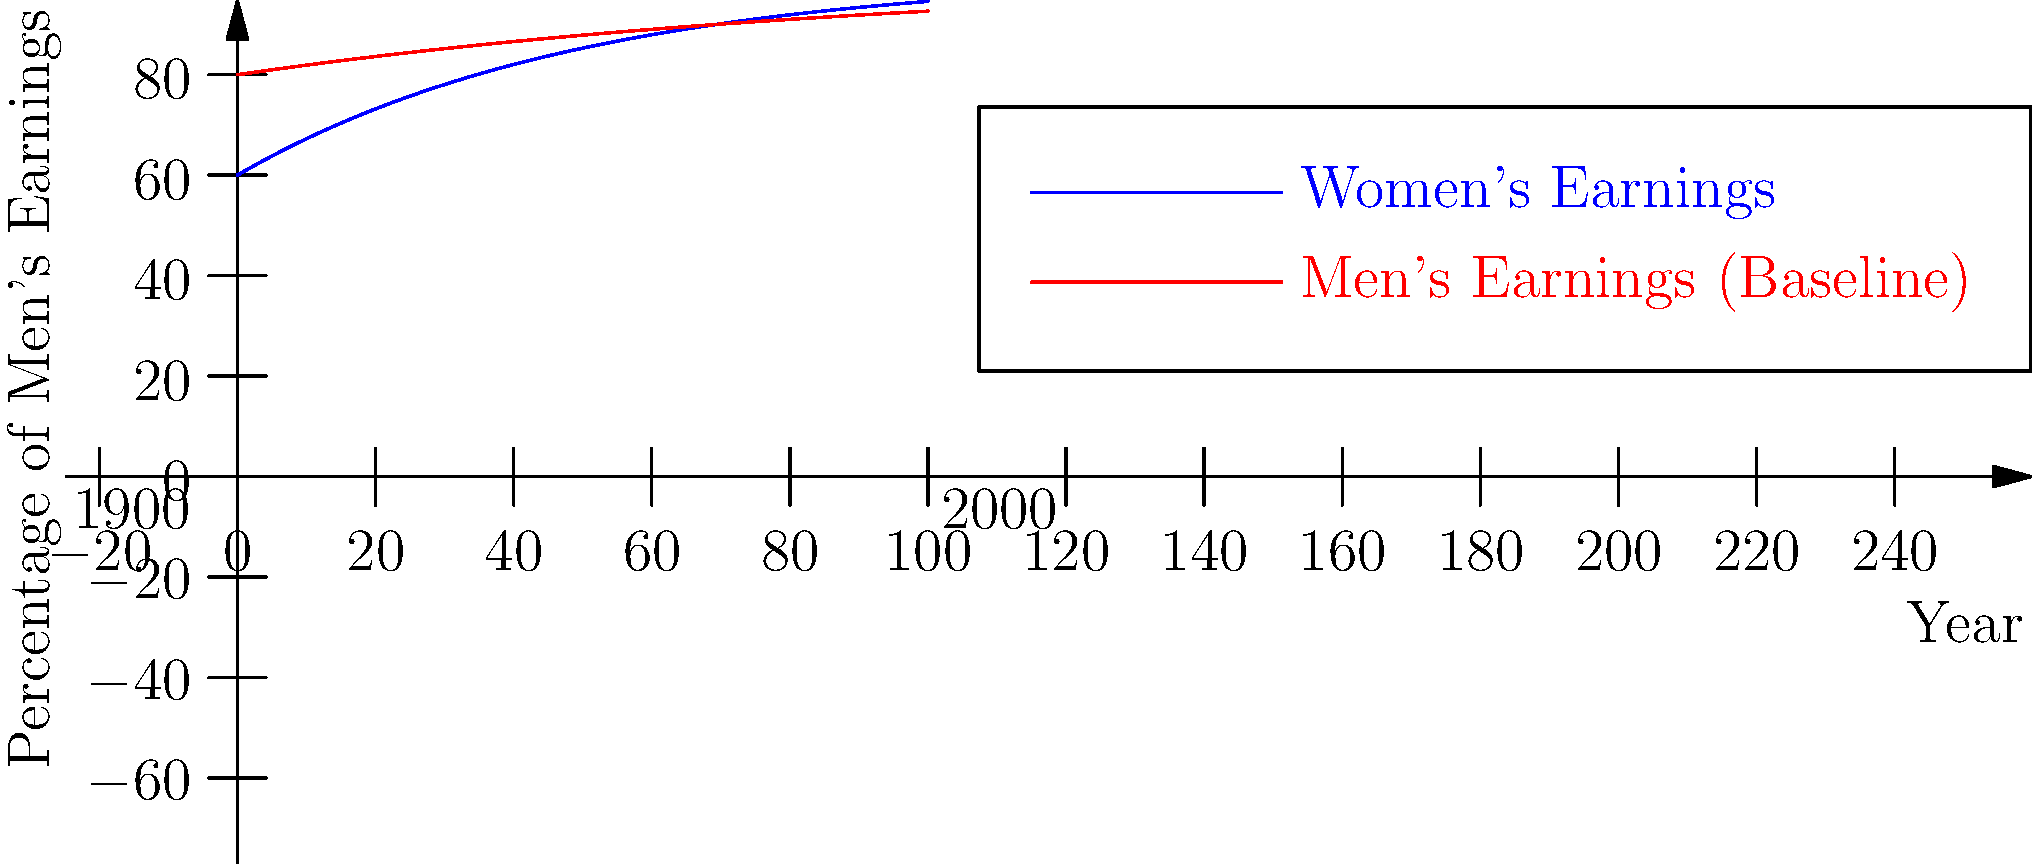Analyze the line graph depicting the gender pay gap trends throughout the 20th century. What does the graph suggest about the progress of women's earnings relative to men's, and what key social or historical factors might explain this trend? To analyze this graph and understand the gender pay gap trends in the 20th century, let's break it down step-by-step:

1. Graph interpretation:
   - The x-axis represents the years from 1900 to 2000.
   - The y-axis shows the percentage of men's earnings.
   - The red line represents men's earnings (baseline at 100%).
   - The blue line represents women's earnings as a percentage of men's.

2. Initial gap:
   - At the start of the century (1900), women's earnings were approximately 60% of men's.

3. Trend over time:
   - The blue line (women's earnings) shows an upward trend throughout the century.
   - The gap between men's and women's earnings narrows over time.

4. Progress rate:
   - The steepest increase in women's earnings occurs between 1960 and 1980.
   - By 2000, women's earnings reach about 80% of men's.

5. Historical factors contributing to this trend:
   a) Women's suffrage movement (early 20th century)
   b) World Wars I and II (women entering workforce)
   c) Civil Rights Movement and Second Wave Feminism (1960s-1970s)
   d) Equal Pay Act of 1963 and Title VII of the Civil Rights Act (1964)
   e) Increased access to higher education for women
   f) Changing social attitudes towards women in the workplace

6. Remaining gap:
   - Despite progress, a significant pay gap still exists at the end of the century.

The graph suggests substantial progress in narrowing the gender pay gap throughout the 20th century, with women's earnings increasing from about 60% to 80% of men's. However, it also shows that complete pay equity was not achieved by the year 2000.
Answer: The graph shows significant progress in reducing the gender pay gap, with women's earnings increasing from 60% to 80% of men's over the century, driven by social movements, legislation, and changing attitudes. 